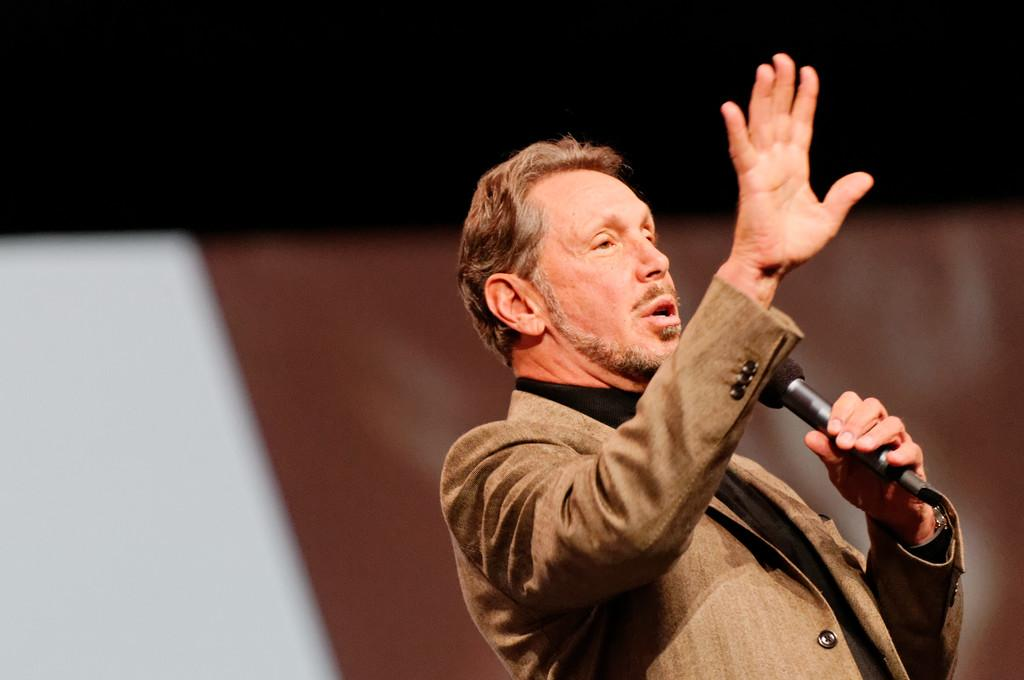What is the man in the image doing? The man is standing in the image and holding a microphone. What accessory is the man wearing? The man is wearing a watch. What colors can be seen in the background of the image? There is a brown color sheet and a white color sheet in the background of the image, with the white sheet specifically on the left side. What type of cabbage is hanging from the ceiling in the image? There is no cabbage present in the image. How does the icicle form in the image? There is no icicle present in the image. 